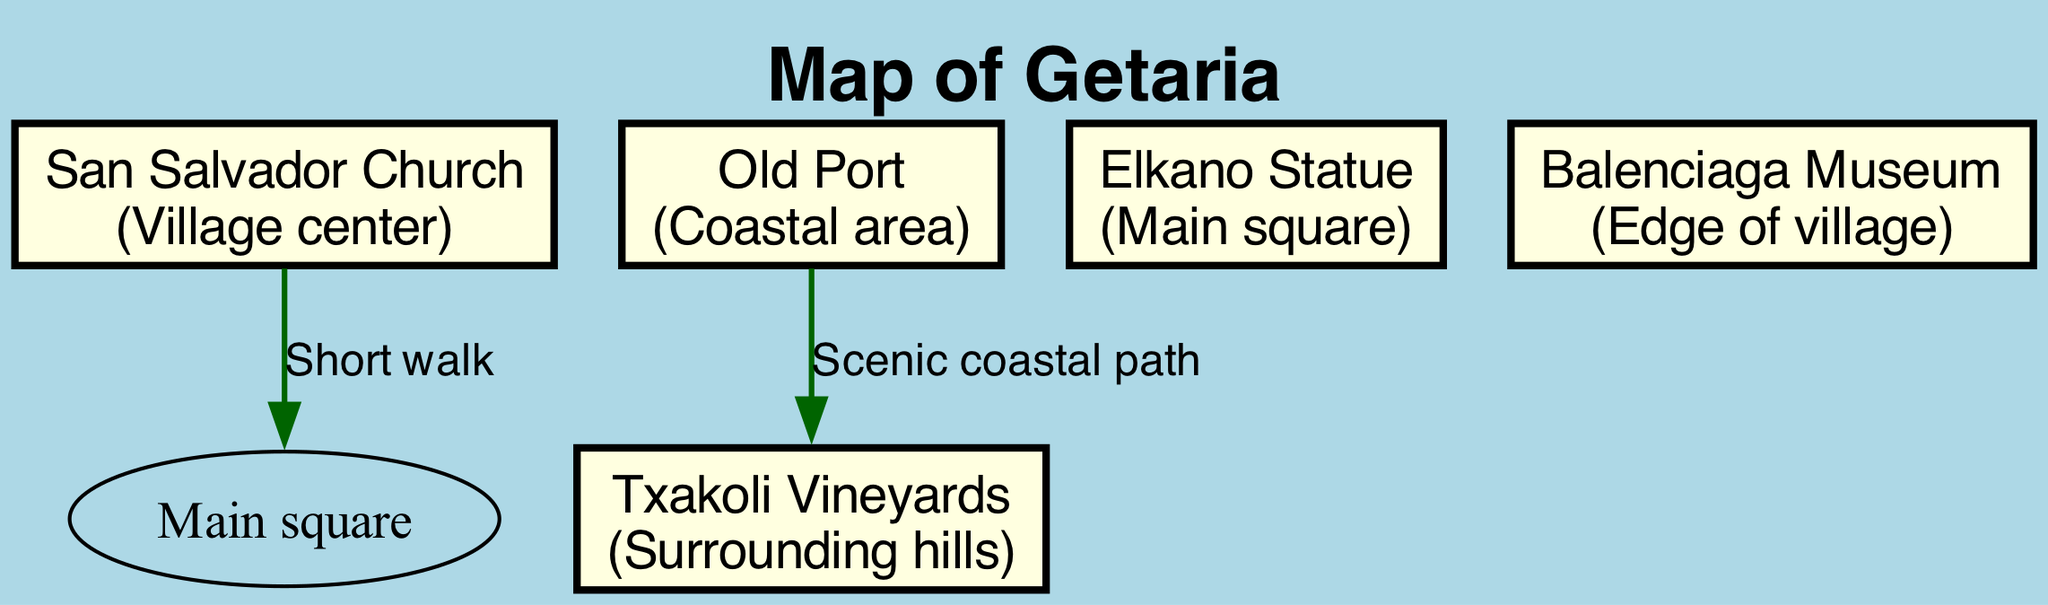What is the name of the church in the village? The church in the village is labeled as "San Salvador Church" on the diagram.
Answer: San Salvador Church How many landmarks are shown on the diagram? The diagram includes five landmarks: San Salvador Church, Old Port, Elkano Statue, Txakoli Vineyards, and Balenciaga Museum. This can be counted directly from the list of landmarks in the diagram.
Answer: 5 Where is the Elkano Statue located? The diagram indicates the Elkano Statue is located in the "Main square." This information can be found by examining the details of the Elkano Statue node.
Answer: Main square What connects the Old Port and the Txakoli Vineyards? The diagram specifies a "Scenic coastal path" as the connection between Old Port and Txakoli Vineyards. This relationship is shown through the edge labeled in the connection section of the diagram.
Answer: Scenic coastal path Which landmark is celebrated for wine production? The Txakoli Vineyards are noted for their traditional Basque white wine production, which is explicitly mentioned in the landmark's significance in the diagram.
Answer: Txakoli Vineyards What is the significance of San Salvador Church? The diagram indicates that the San Salvador Church is a "16th-century Gothic church, heart of community." This information is stated directly under the church's name in the diagram.
Answer: 16th-century Gothic church, heart of community Which landmark is located at the edge of the village? The Balenciaga Museum is identified as being located at the "Edge of village" in the diagram, which can be directly referenced from its placement on the map.
Answer: Edge of village What type of connection is there from the San Salvador Church to the Main Square? The connection is described as a "Short walk." This is labeled on the edge connecting these two landmarks in the diagram.
Answer: Short walk What historical figure is honored by the Elkano Statue? The Elkano Statue honors a local explorer who completed the first circumnavigation. This significance is explicitly stated in the monument's details shown in the diagram.
Answer: Local explorer who completed first circumnavigation 